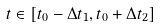Convert formula to latex. <formula><loc_0><loc_0><loc_500><loc_500>t \in \left [ t _ { 0 } - \Delta t _ { 1 } , t _ { 0 } + \Delta t _ { 2 } \right ]</formula> 